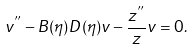<formula> <loc_0><loc_0><loc_500><loc_500>v ^ { ^ { \prime \prime } } - B ( \eta ) D ( \eta ) v - \frac { z ^ { ^ { \prime \prime } } } { z } v = 0 .</formula> 